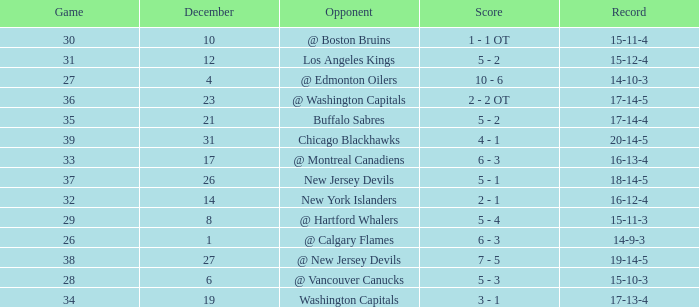Game smaller than 34, and a December smaller than 14, and a Score of 10 - 6 has what opponent? @ Edmonton Oilers. 